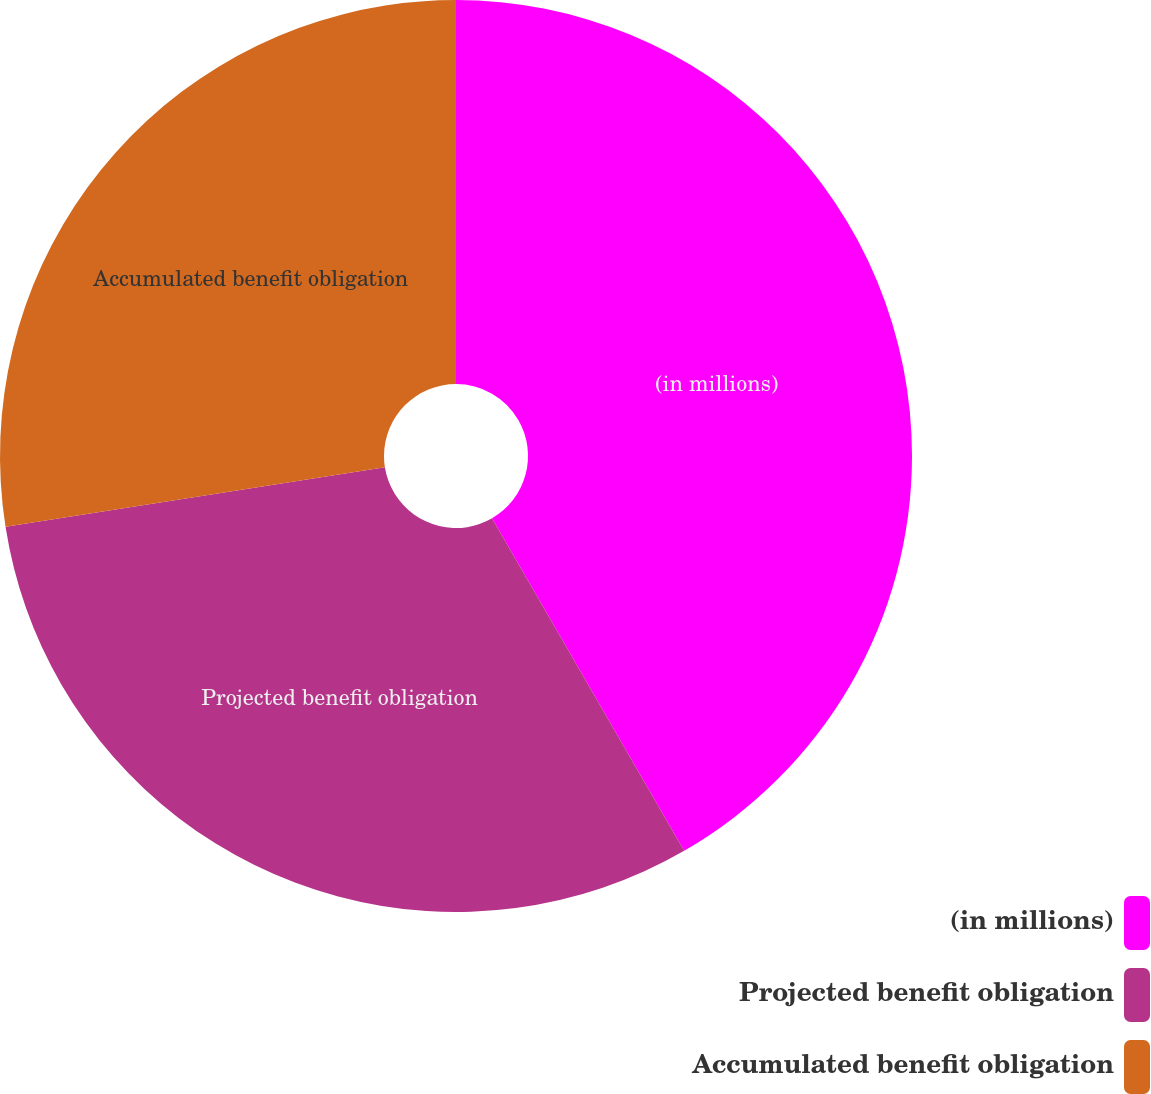Convert chart. <chart><loc_0><loc_0><loc_500><loc_500><pie_chart><fcel>(in millions)<fcel>Projected benefit obligation<fcel>Accumulated benefit obligation<nl><fcel>41.66%<fcel>30.86%<fcel>27.48%<nl></chart> 